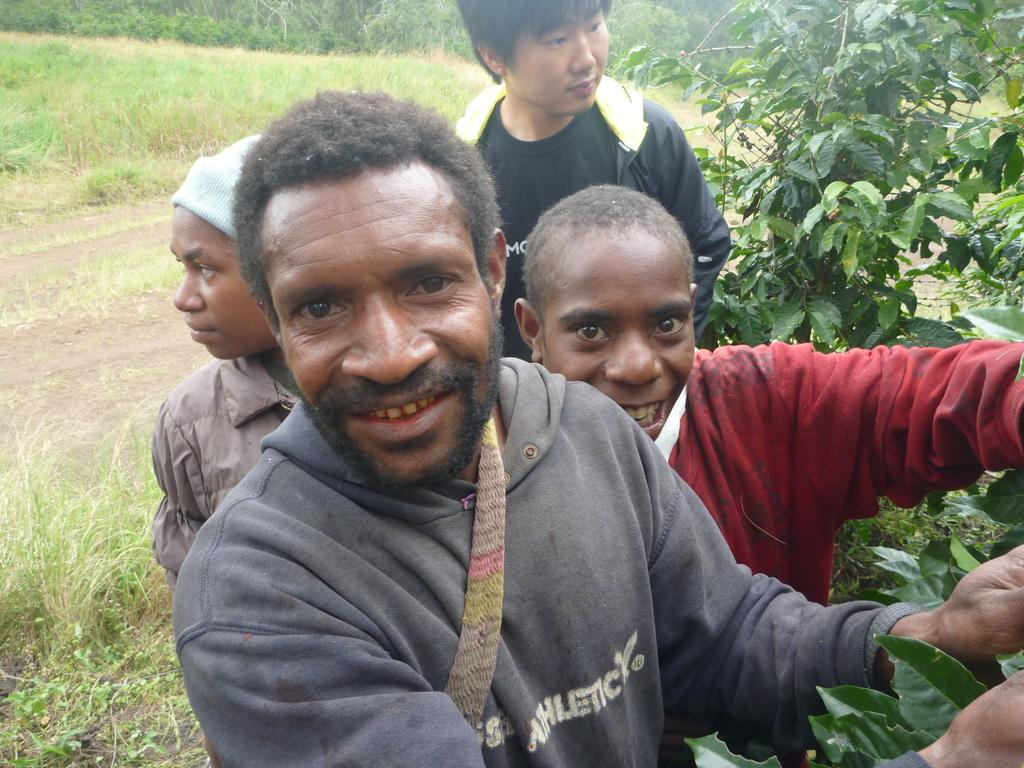How many people are in the image? There are four people standing in the center of the image. What can be seen on the right side of the image? There is a tree on the right side of the image. What type of vegetation is visible in the background of the image? There is grass visible in the background of the image. What type of hen can be seen perched on the tree in the image? There is no hen present in the image; it only features four people and a tree. Can you tell me how many berries are on the tree in the image? There are no berries visible on the tree in the image. 